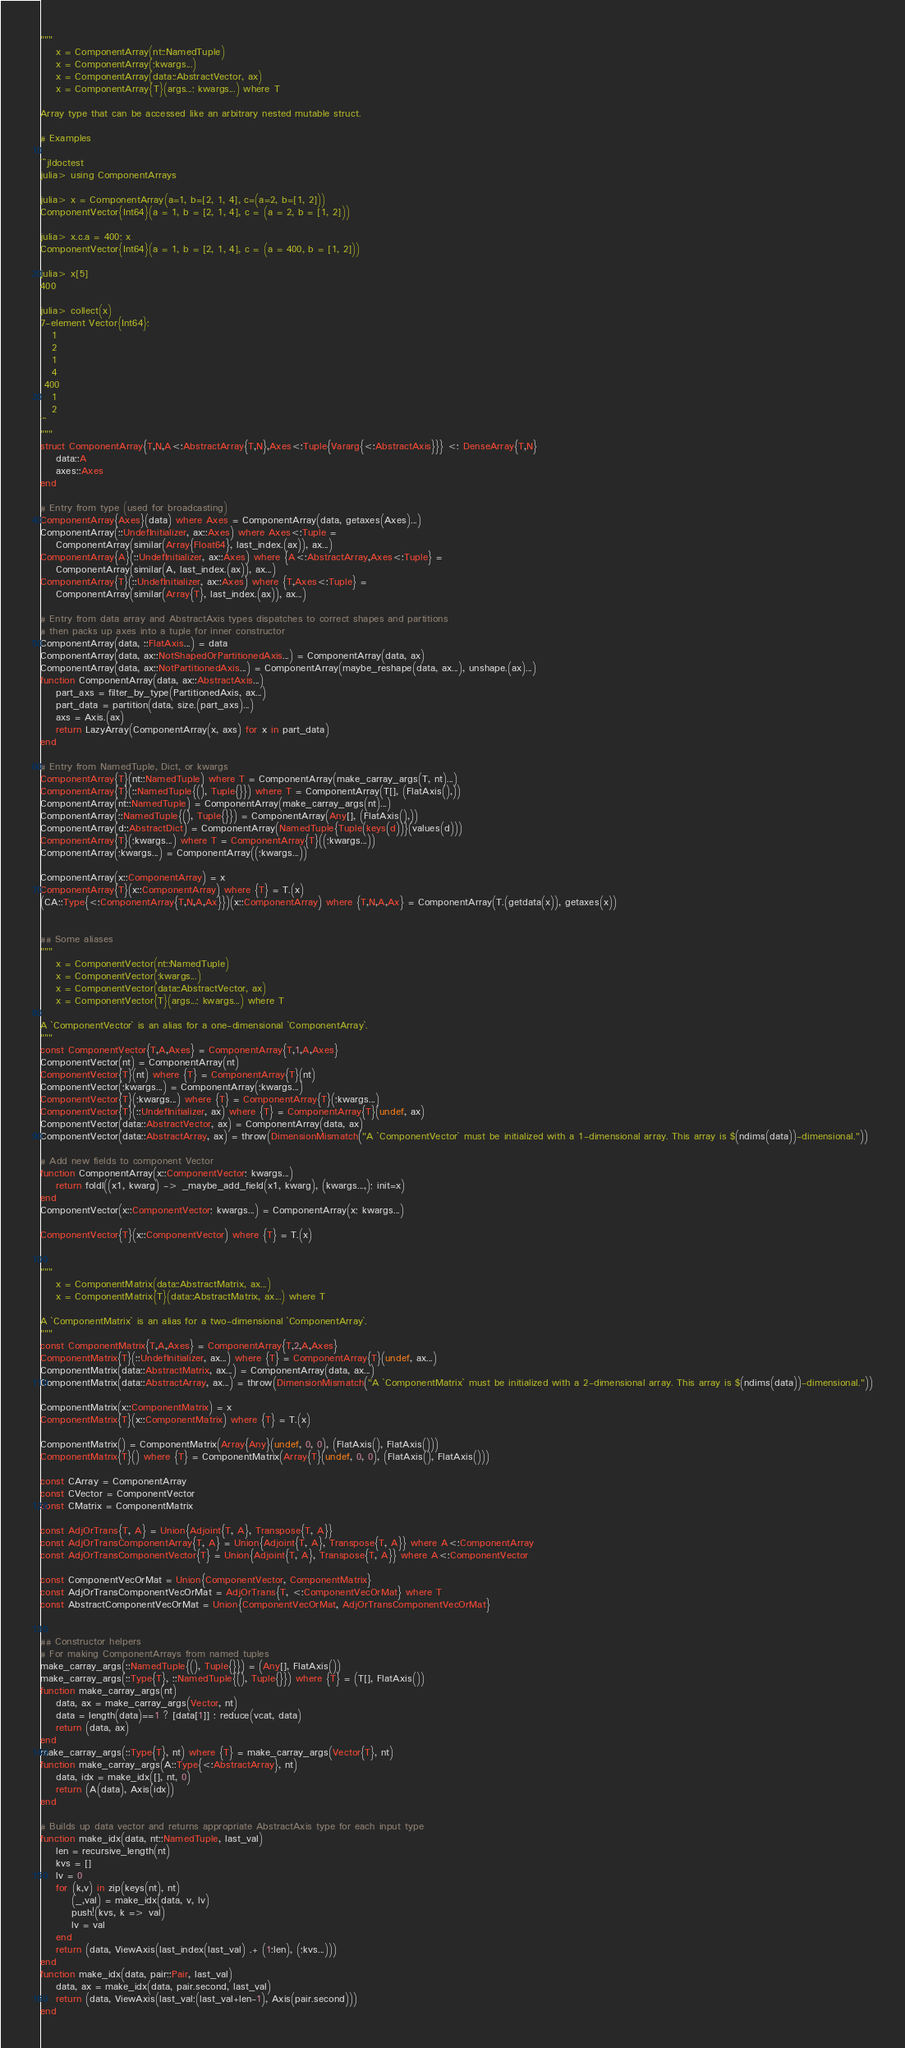Convert code to text. <code><loc_0><loc_0><loc_500><loc_500><_Julia_>"""
    x = ComponentArray(nt::NamedTuple)
    x = ComponentArray(;kwargs...)
    x = ComponentArray(data::AbstractVector, ax)
    x = ComponentArray{T}(args...; kwargs...) where T

Array type that can be accessed like an arbitrary nested mutable struct.

# Examples

```jldoctest
julia> using ComponentArrays

julia> x = ComponentArray(a=1, b=[2, 1, 4], c=(a=2, b=[1, 2]))
ComponentVector{Int64}(a = 1, b = [2, 1, 4], c = (a = 2, b = [1, 2]))

julia> x.c.a = 400; x
ComponentVector{Int64}(a = 1, b = [2, 1, 4], c = (a = 400, b = [1, 2]))

julia> x[5]
400

julia> collect(x)
7-element Vector{Int64}:
   1
   2
   1
   4
 400
   1
   2
```
"""
struct ComponentArray{T,N,A<:AbstractArray{T,N},Axes<:Tuple{Vararg{<:AbstractAxis}}} <: DenseArray{T,N}
    data::A
    axes::Axes
end

# Entry from type (used for broadcasting)
ComponentArray{Axes}(data) where Axes = ComponentArray(data, getaxes(Axes)...)
ComponentArray(::UndefInitializer, ax::Axes) where Axes<:Tuple =
    ComponentArray(similar(Array{Float64}, last_index.(ax)), ax...)
ComponentArray{A}(::UndefInitializer, ax::Axes) where {A<:AbstractArray,Axes<:Tuple} =
    ComponentArray(similar(A, last_index.(ax)), ax...)
ComponentArray{T}(::UndefInitializer, ax::Axes) where {T,Axes<:Tuple} =
    ComponentArray(similar(Array{T}, last_index.(ax)), ax...)

# Entry from data array and AbstractAxis types dispatches to correct shapes and partitions
# then packs up axes into a tuple for inner constructor
ComponentArray(data, ::FlatAxis...) = data
ComponentArray(data, ax::NotShapedOrPartitionedAxis...) = ComponentArray(data, ax)
ComponentArray(data, ax::NotPartitionedAxis...) = ComponentArray(maybe_reshape(data, ax...), unshape.(ax)...)
function ComponentArray(data, ax::AbstractAxis...)
    part_axs = filter_by_type(PartitionedAxis, ax...)
    part_data = partition(data, size.(part_axs)...)
    axs = Axis.(ax)
    return LazyArray(ComponentArray(x, axs) for x in part_data)
end

# Entry from NamedTuple, Dict, or kwargs
ComponentArray{T}(nt::NamedTuple) where T = ComponentArray(make_carray_args(T, nt)...)
ComponentArray{T}(::NamedTuple{(), Tuple{}}) where T = ComponentArray(T[], (FlatAxis(),))
ComponentArray(nt::NamedTuple) = ComponentArray(make_carray_args(nt)...)
ComponentArray(::NamedTuple{(), Tuple{}}) = ComponentArray(Any[], (FlatAxis(),))
ComponentArray(d::AbstractDict) = ComponentArray(NamedTuple{Tuple(keys(d))}(values(d)))
ComponentArray{T}(;kwargs...) where T = ComponentArray{T}((;kwargs...))
ComponentArray(;kwargs...) = ComponentArray((;kwargs...))

ComponentArray(x::ComponentArray) = x
ComponentArray{T}(x::ComponentArray) where {T} = T.(x)
(CA::Type{<:ComponentArray{T,N,A,Ax}})(x::ComponentArray) where {T,N,A,Ax} = ComponentArray(T.(getdata(x)), getaxes(x))


## Some aliases
"""
    x = ComponentVector(nt::NamedTuple)
    x = ComponentVector(;kwargs...)
    x = ComponentVector(data::AbstractVector, ax)
    x = ComponentVector{T}(args...; kwargs...) where T

A `ComponentVector` is an alias for a one-dimensional `ComponentArray`.
"""
const ComponentVector{T,A,Axes} = ComponentArray{T,1,A,Axes}
ComponentVector(nt) = ComponentArray(nt)
ComponentVector{T}(nt) where {T} = ComponentArray{T}(nt)
ComponentVector(;kwargs...) = ComponentArray(;kwargs...)
ComponentVector{T}(;kwargs...) where {T} = ComponentArray{T}(;kwargs...)
ComponentVector{T}(::UndefInitializer, ax) where {T} = ComponentArray{T}(undef, ax)
ComponentVector(data::AbstractVector, ax) = ComponentArray(data, ax)
ComponentVector(data::AbstractArray, ax) = throw(DimensionMismatch("A `ComponentVector` must be initialized with a 1-dimensional array. This array is $(ndims(data))-dimensional."))

# Add new fields to component Vector
function ComponentArray(x::ComponentVector; kwargs...)
    return foldl((x1, kwarg) -> _maybe_add_field(x1, kwarg), (kwargs...,); init=x)
end
ComponentVector(x::ComponentVector; kwargs...) = ComponentArray(x; kwargs...)

ComponentVector{T}(x::ComponentVector) where {T} = T.(x)


"""
    x = ComponentMatrix(data::AbstractMatrix, ax...)
    x = ComponentMatrix{T}(data::AbstractMatrix, ax...) where T

A `ComponentMatrix` is an alias for a two-dimensional `ComponentArray`.
"""
const ComponentMatrix{T,A,Axes} = ComponentArray{T,2,A,Axes}
ComponentMatrix{T}(::UndefInitializer, ax...) where {T} = ComponentArray{T}(undef, ax...)
ComponentMatrix(data::AbstractMatrix, ax...) = ComponentArray(data, ax...)
ComponentMatrix(data::AbstractArray, ax...) = throw(DimensionMismatch("A `ComponentMatrix` must be initialized with a 2-dimensional array. This array is $(ndims(data))-dimensional."))

ComponentMatrix(x::ComponentMatrix) = x
ComponentMatrix{T}(x::ComponentMatrix) where {T} = T.(x)

ComponentMatrix() = ComponentMatrix(Array{Any}(undef, 0, 0), (FlatAxis(), FlatAxis()))
ComponentMatrix{T}() where {T} = ComponentMatrix(Array{T}(undef, 0, 0), (FlatAxis(), FlatAxis()))

const CArray = ComponentArray
const CVector = ComponentVector
const CMatrix = ComponentMatrix

const AdjOrTrans{T, A} = Union{Adjoint{T, A}, Transpose{T, A}}
const AdjOrTransComponentArray{T, A} = Union{Adjoint{T, A}, Transpose{T, A}} where A<:ComponentArray
const AdjOrTransComponentVector{T} = Union{Adjoint{T, A}, Transpose{T, A}} where A<:ComponentVector

const ComponentVecOrMat = Union{ComponentVector, ComponentMatrix}
const AdjOrTransComponentVecOrMat = AdjOrTrans{T, <:ComponentVecOrMat} where T
const AbstractComponentVecOrMat = Union{ComponentVecOrMat, AdjOrTransComponentVecOrMat}


## Constructor helpers
# For making ComponentArrays from named tuples
make_carray_args(::NamedTuple{(), Tuple{}}) = (Any[], FlatAxis())
make_carray_args(::Type{T}, ::NamedTuple{(), Tuple{}}) where {T} = (T[], FlatAxis())
function make_carray_args(nt)
    data, ax = make_carray_args(Vector, nt)
    data = length(data)==1 ? [data[1]] : reduce(vcat, data)
    return (data, ax)
end
make_carray_args(::Type{T}, nt) where {T} = make_carray_args(Vector{T}, nt)
function make_carray_args(A::Type{<:AbstractArray}, nt)
    data, idx = make_idx([], nt, 0)
    return (A(data), Axis(idx))
end

# Builds up data vector and returns appropriate AbstractAxis type for each input type
function make_idx(data, nt::NamedTuple, last_val)
    len = recursive_length(nt)
    kvs = []
    lv = 0
    for (k,v) in zip(keys(nt), nt)
        (_,val) = make_idx(data, v, lv)
        push!(kvs, k => val)
        lv = val
    end
    return (data, ViewAxis(last_index(last_val) .+ (1:len), (;kvs...)))
end
function make_idx(data, pair::Pair, last_val)
    data, ax = make_idx(data, pair.second, last_val)
    return (data, ViewAxis(last_val:(last_val+len-1), Axis(pair.second)))
end</code> 